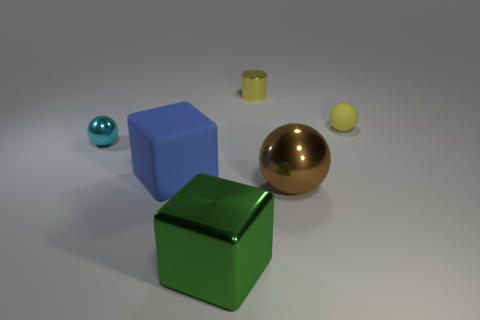Add 3 small blue metal cylinders. How many objects exist? 9 Subtract all cylinders. How many objects are left? 5 Subtract 0 brown cubes. How many objects are left? 6 Subtract all large gray spheres. Subtract all small metal cylinders. How many objects are left? 5 Add 6 large brown things. How many large brown things are left? 7 Add 4 cubes. How many cubes exist? 6 